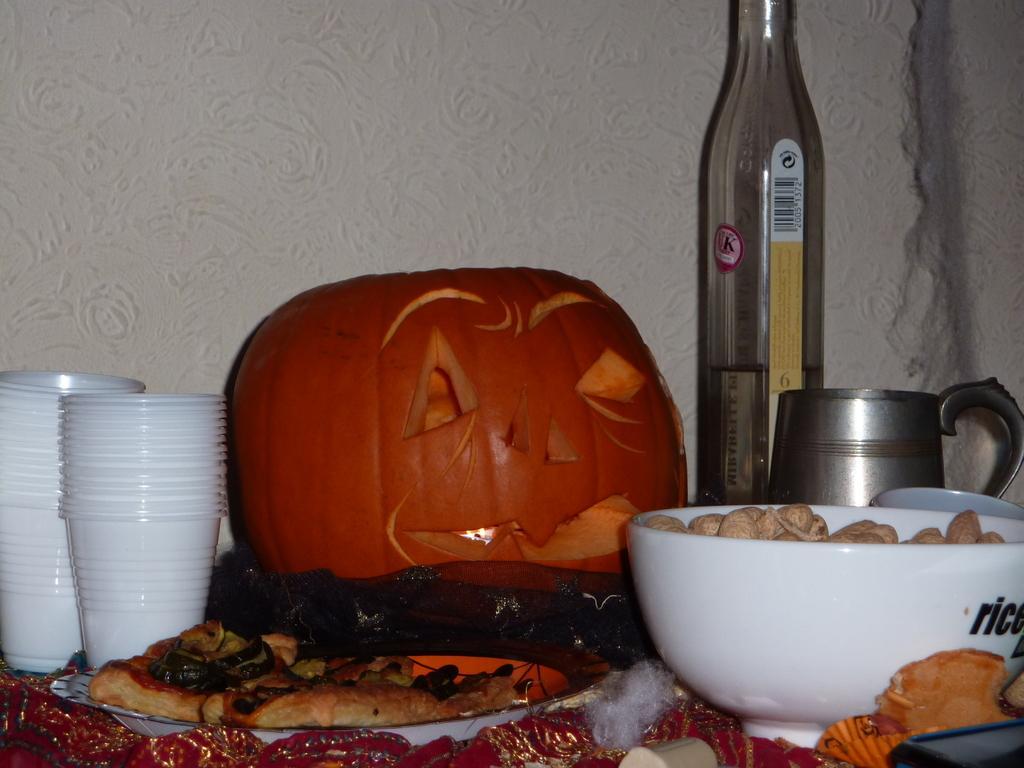Describe this image in one or two sentences. In this image there are cups, food in the plate and bowl, pumpkin and bottle. At the bottom there is a red color cloth. 